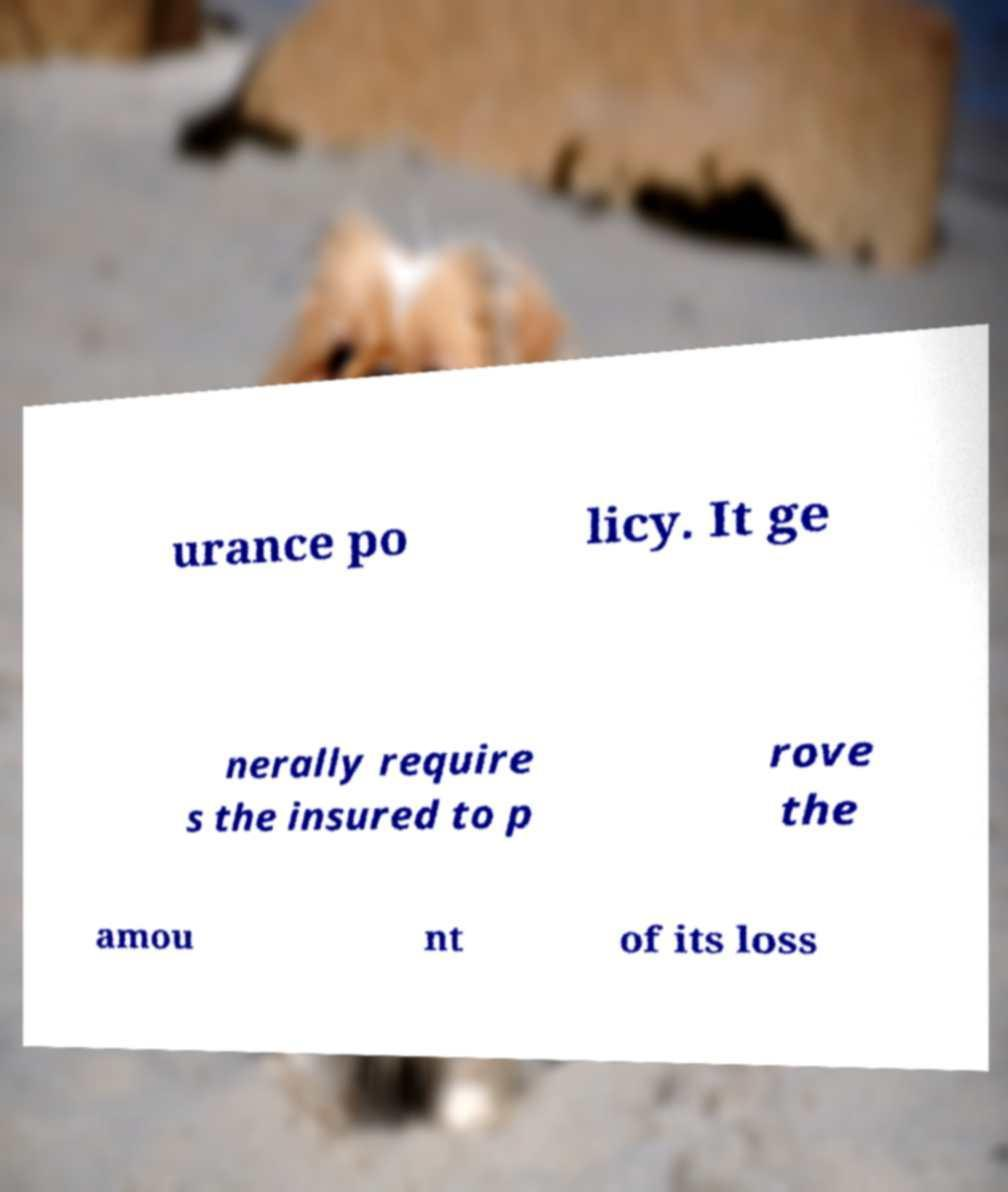For documentation purposes, I need the text within this image transcribed. Could you provide that? urance po licy. It ge nerally require s the insured to p rove the amou nt of its loss 